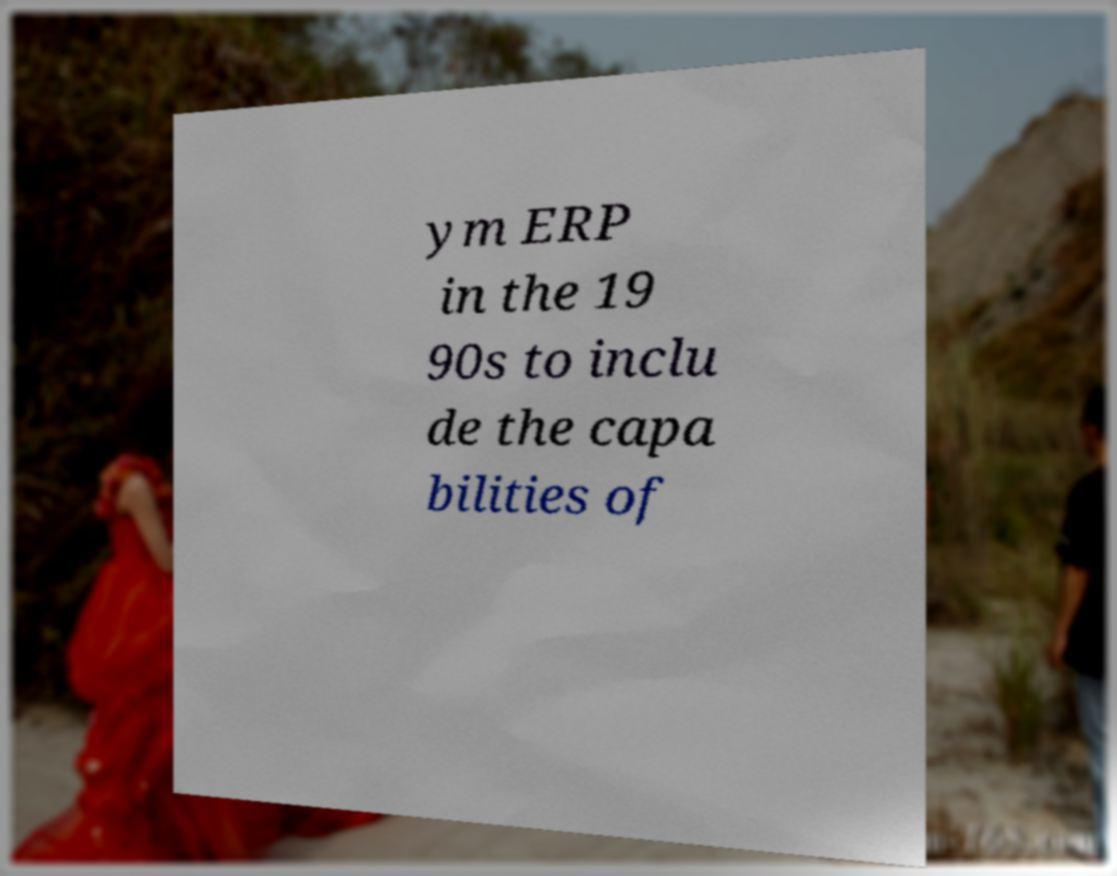What messages or text are displayed in this image? I need them in a readable, typed format. ym ERP in the 19 90s to inclu de the capa bilities of 